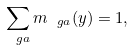<formula> <loc_0><loc_0><loc_500><loc_500>\sum _ { \ g a } m _ { \ g a } ( y ) = 1 ,</formula> 